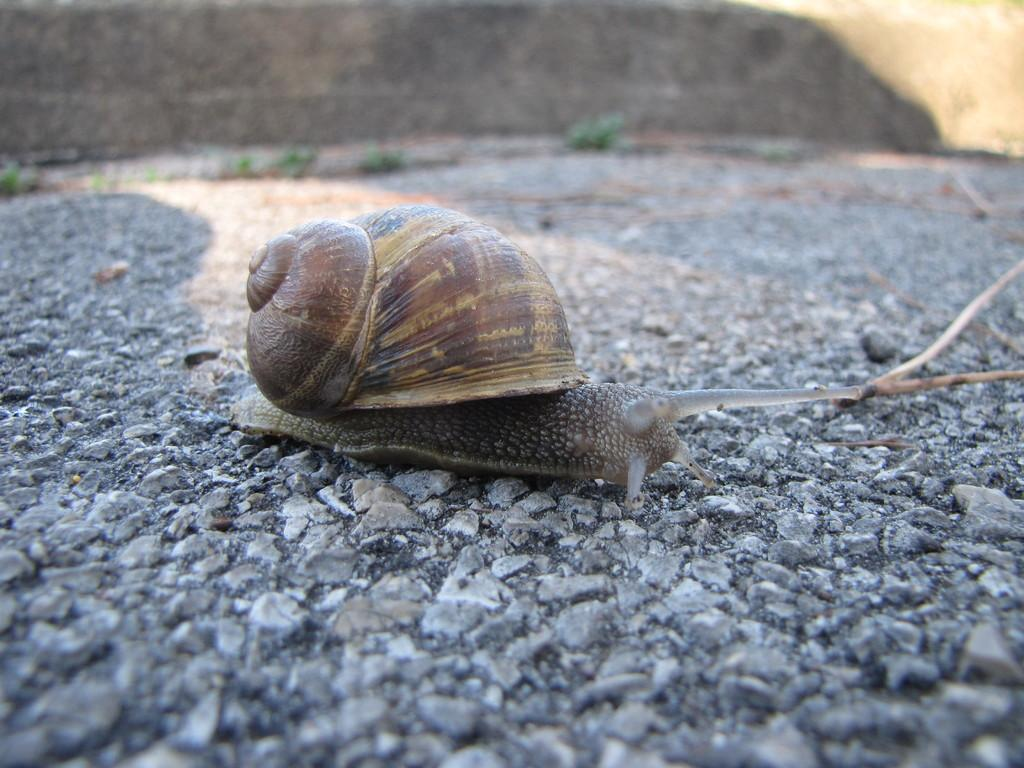What type of animal is in the image? There is a snail in the image. Where is the snail located? The snail is on the ground. Can you describe the background of the image? The background of the image is blurred. What type of stove is visible in the image? There is no stove present in the image; it features a snail on the ground with a blurred background. 